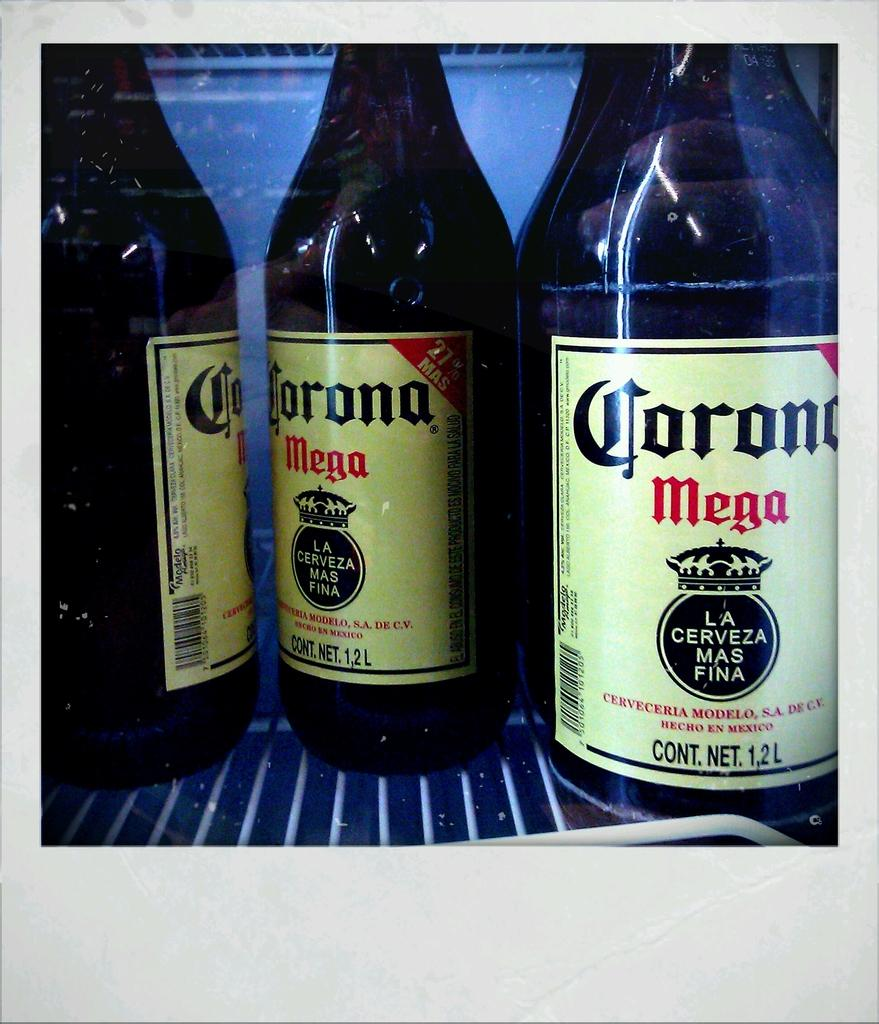What objects are present in the image? There are bottles in the image. What can be seen on the bottles? There is text written on the bottles. Where are the bottles placed? The bottles are on a grill stand. What is the color of the grill stand? The grill stand is white in color. Can you tell me how many grapes are on the grill stand in the image? There are no grapes present in the image; it features bottles on a grill stand. What type of note is attached to the bottles in the image? There is no note attached to the bottles in the image; only text is written on them. 